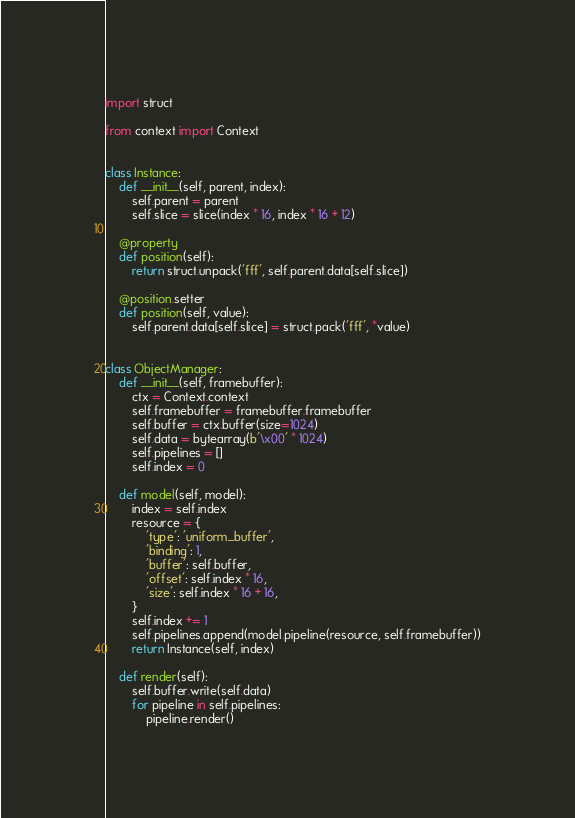<code> <loc_0><loc_0><loc_500><loc_500><_Python_>import struct

from context import Context


class Instance:
    def __init__(self, parent, index):
        self.parent = parent
        self.slice = slice(index * 16, index * 16 + 12)

    @property
    def position(self):
        return struct.unpack('fff', self.parent.data[self.slice])

    @position.setter
    def position(self, value):
        self.parent.data[self.slice] = struct.pack('fff', *value)


class ObjectManager:
    def __init__(self, framebuffer):
        ctx = Context.context
        self.framebuffer = framebuffer.framebuffer
        self.buffer = ctx.buffer(size=1024)
        self.data = bytearray(b'\x00' * 1024)
        self.pipelines = []
        self.index = 0

    def model(self, model):
        index = self.index
        resource = {
            'type': 'uniform_buffer',
            'binding': 1,
            'buffer': self.buffer,
            'offset': self.index * 16,
            'size': self.index * 16 + 16,
        }
        self.index += 1
        self.pipelines.append(model.pipeline(resource, self.framebuffer))
        return Instance(self, index)

    def render(self):
        self.buffer.write(self.data)
        for pipeline in self.pipelines:
            pipeline.render()
</code> 